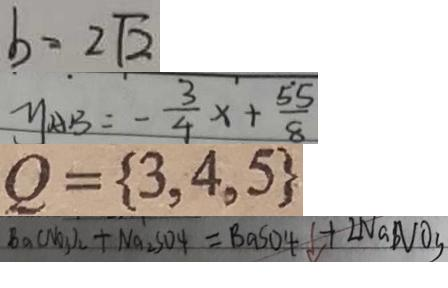Convert formula to latex. <formula><loc_0><loc_0><loc_500><loc_500>b = 2 \sqrt { 2 } 
 y _ { A B } = - \frac { 3 } { 4 } x + \frac { 5 5 } { 8 } 
 Q = \{ 3 , 4 , 5 \} 
 B a ( N O _ { 3 } ) _ { 2 } + N a _ { 2 } S O _ { 4 } = B a S O _ { 4 } \downarrow + 2 N a N O _ { 3 }</formula> 